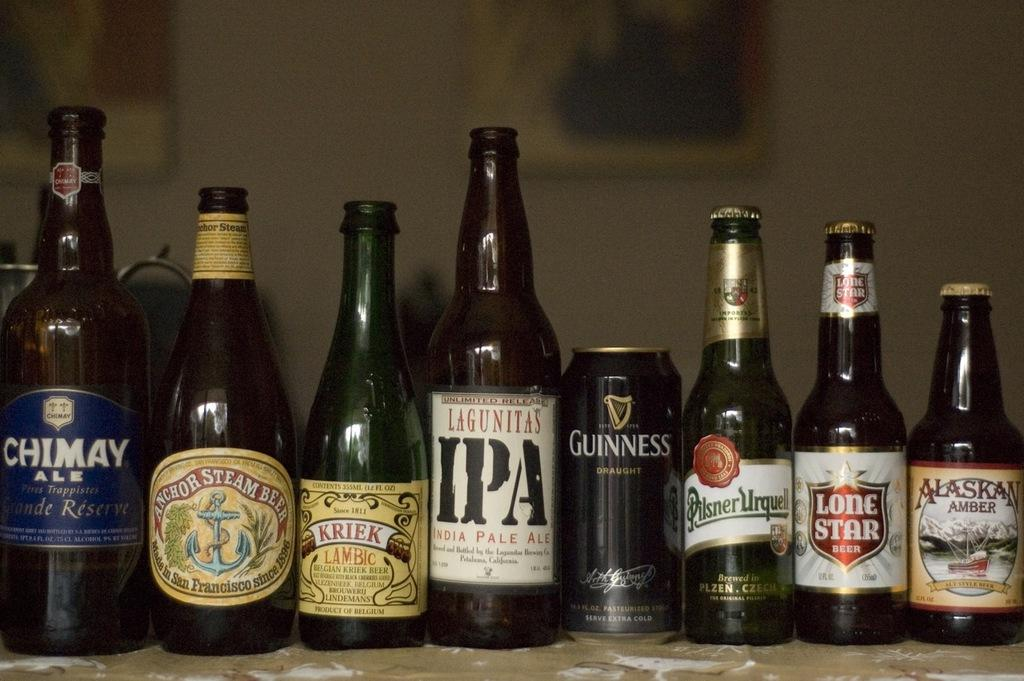<image>
Give a short and clear explanation of the subsequent image. A row of beer bottles including Chimay Ale and Lagunitas IPA. 